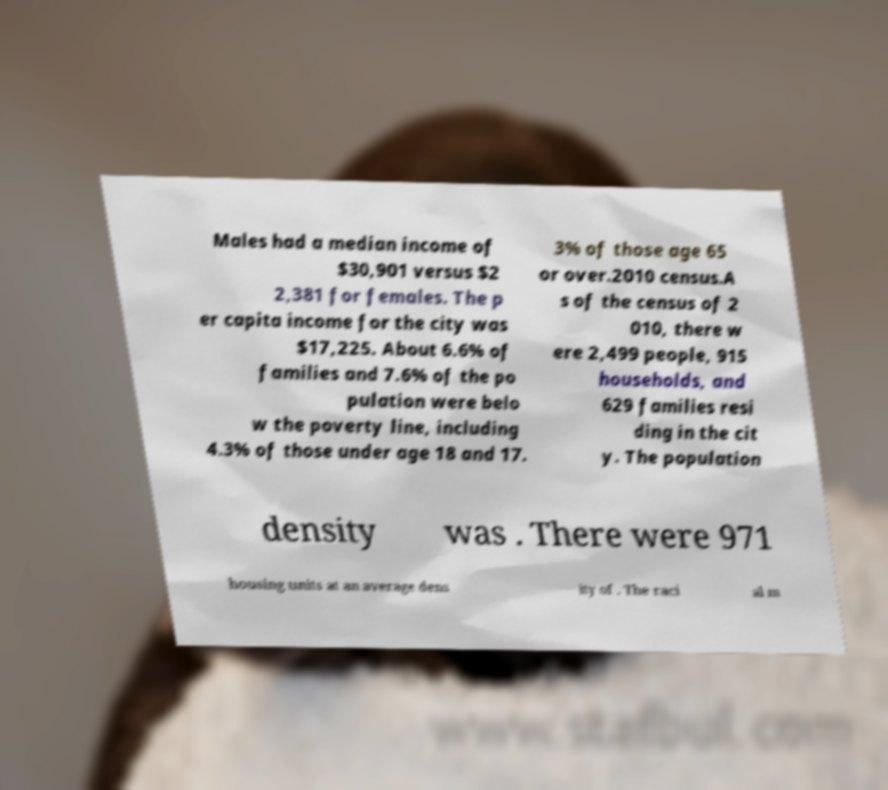Can you read and provide the text displayed in the image?This photo seems to have some interesting text. Can you extract and type it out for me? Males had a median income of $30,901 versus $2 2,381 for females. The p er capita income for the city was $17,225. About 6.6% of families and 7.6% of the po pulation were belo w the poverty line, including 4.3% of those under age 18 and 17. 3% of those age 65 or over.2010 census.A s of the census of 2 010, there w ere 2,499 people, 915 households, and 629 families resi ding in the cit y. The population density was . There were 971 housing units at an average dens ity of . The raci al m 